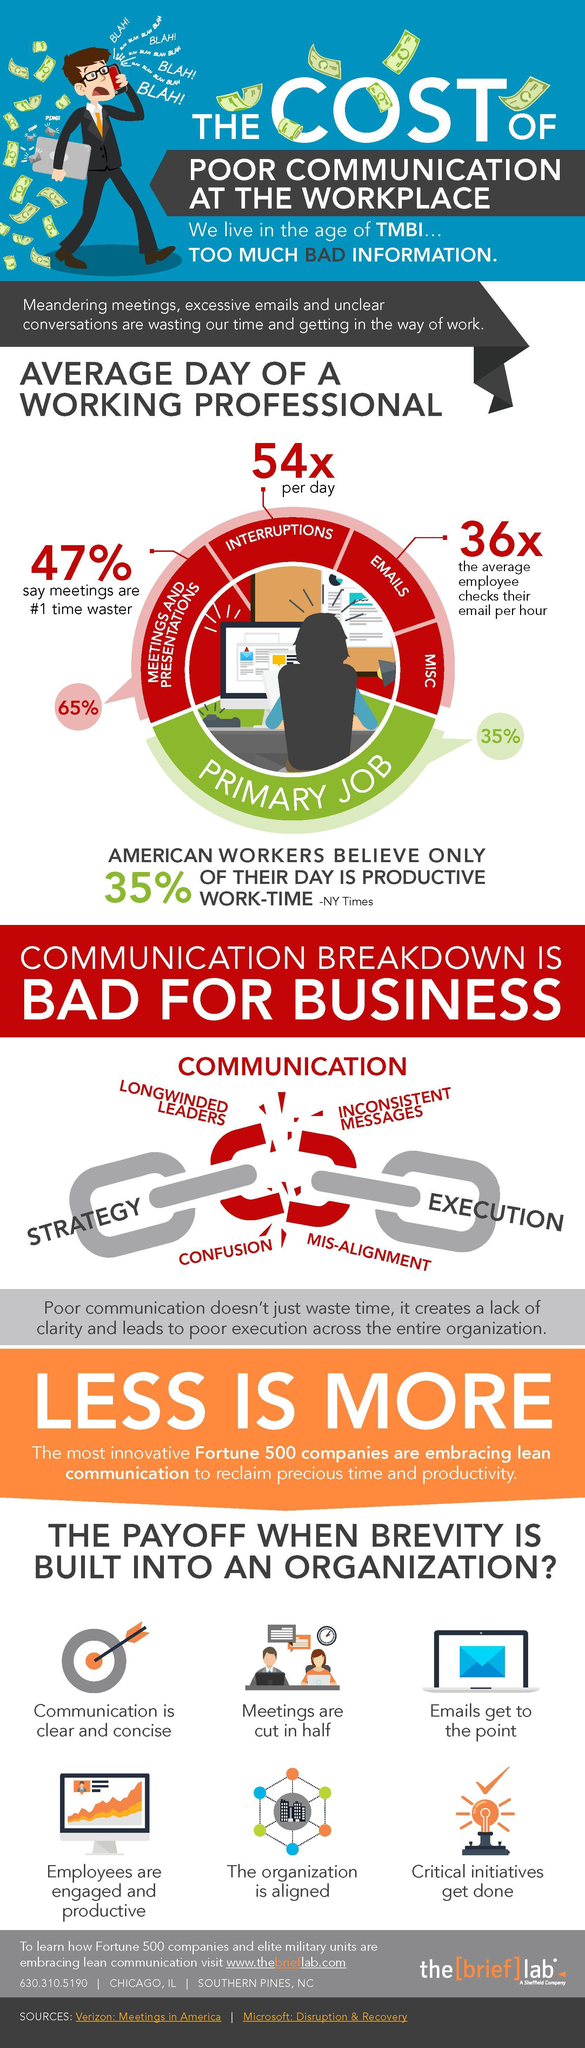What amount of time in a work day is believed as not productive for Americans?
Answer the question with a short phrase. 65 How many possible disruptions against productive work time are listed in the info graphic? 4 What percent of organisations does not believe that meetings are the primary reason for waste of work time? 53 